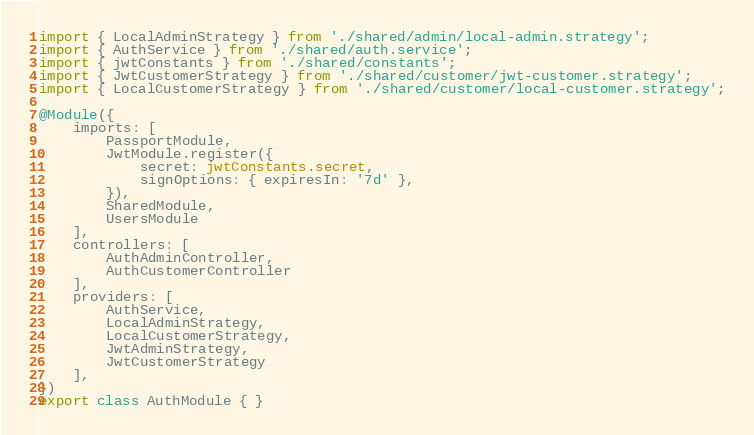<code> <loc_0><loc_0><loc_500><loc_500><_TypeScript_>import { LocalAdminStrategy } from './shared/admin/local-admin.strategy';
import { AuthService } from './shared/auth.service';
import { jwtConstants } from './shared/constants';
import { JwtCustomerStrategy } from './shared/customer/jwt-customer.strategy';
import { LocalCustomerStrategy } from './shared/customer/local-customer.strategy';

@Module({
    imports: [
        PassportModule,
        JwtModule.register({
            secret: jwtConstants.secret,
            signOptions: { expiresIn: '7d' },
        }),
        SharedModule,
        UsersModule
    ],
    controllers: [
        AuthAdminController,
        AuthCustomerController
    ],
    providers: [
        AuthService,
        LocalAdminStrategy,
        LocalCustomerStrategy,
        JwtAdminStrategy,
        JwtCustomerStrategy
    ],
})
export class AuthModule { }</code> 